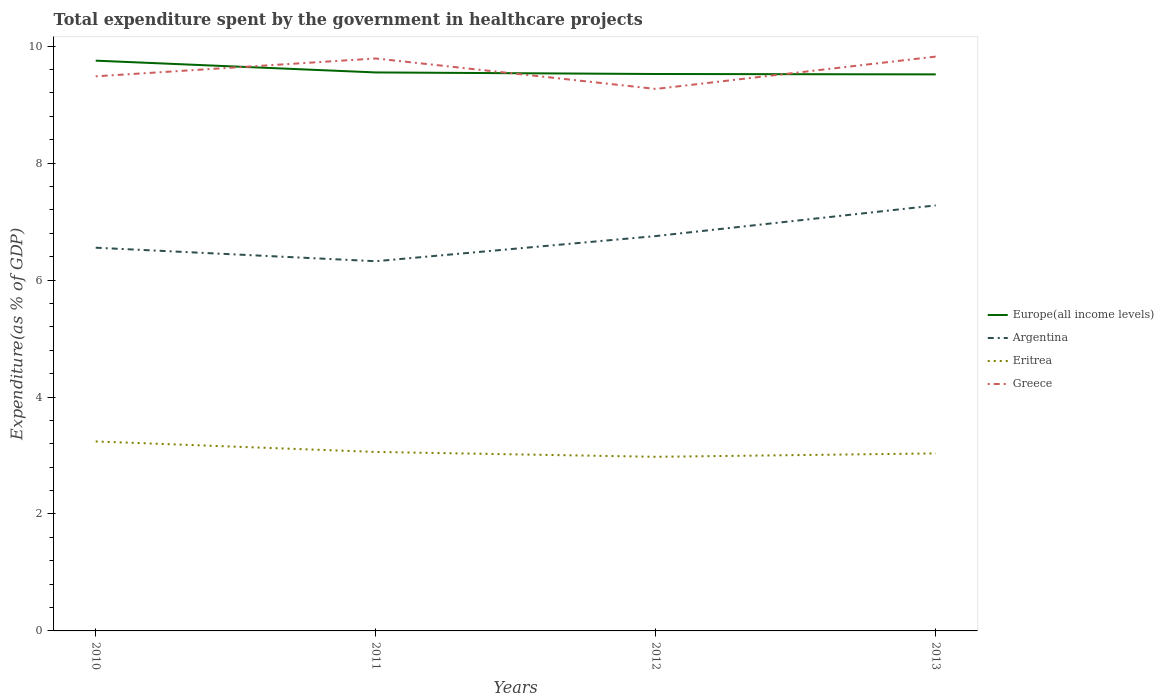Across all years, what is the maximum total expenditure spent by the government in healthcare projects in Greece?
Give a very brief answer. 9.27. What is the total total expenditure spent by the government in healthcare projects in Europe(all income levels) in the graph?
Make the answer very short. 0.2. What is the difference between the highest and the second highest total expenditure spent by the government in healthcare projects in Argentina?
Offer a very short reply. 0.95. Are the values on the major ticks of Y-axis written in scientific E-notation?
Give a very brief answer. No. What is the title of the graph?
Provide a succinct answer. Total expenditure spent by the government in healthcare projects. Does "Moldova" appear as one of the legend labels in the graph?
Provide a short and direct response. No. What is the label or title of the X-axis?
Make the answer very short. Years. What is the label or title of the Y-axis?
Your answer should be very brief. Expenditure(as % of GDP). What is the Expenditure(as % of GDP) of Europe(all income levels) in 2010?
Make the answer very short. 9.75. What is the Expenditure(as % of GDP) in Argentina in 2010?
Provide a short and direct response. 6.55. What is the Expenditure(as % of GDP) of Eritrea in 2010?
Your answer should be compact. 3.24. What is the Expenditure(as % of GDP) in Greece in 2010?
Give a very brief answer. 9.48. What is the Expenditure(as % of GDP) of Europe(all income levels) in 2011?
Provide a short and direct response. 9.55. What is the Expenditure(as % of GDP) of Argentina in 2011?
Your answer should be compact. 6.32. What is the Expenditure(as % of GDP) in Eritrea in 2011?
Give a very brief answer. 3.06. What is the Expenditure(as % of GDP) of Greece in 2011?
Ensure brevity in your answer.  9.79. What is the Expenditure(as % of GDP) in Europe(all income levels) in 2012?
Keep it short and to the point. 9.52. What is the Expenditure(as % of GDP) of Argentina in 2012?
Provide a succinct answer. 6.75. What is the Expenditure(as % of GDP) in Eritrea in 2012?
Offer a very short reply. 2.98. What is the Expenditure(as % of GDP) of Greece in 2012?
Your answer should be very brief. 9.27. What is the Expenditure(as % of GDP) of Europe(all income levels) in 2013?
Your response must be concise. 9.52. What is the Expenditure(as % of GDP) of Argentina in 2013?
Keep it short and to the point. 7.28. What is the Expenditure(as % of GDP) in Eritrea in 2013?
Keep it short and to the point. 3.04. What is the Expenditure(as % of GDP) of Greece in 2013?
Your response must be concise. 9.82. Across all years, what is the maximum Expenditure(as % of GDP) of Europe(all income levels)?
Offer a very short reply. 9.75. Across all years, what is the maximum Expenditure(as % of GDP) of Argentina?
Make the answer very short. 7.28. Across all years, what is the maximum Expenditure(as % of GDP) of Eritrea?
Give a very brief answer. 3.24. Across all years, what is the maximum Expenditure(as % of GDP) in Greece?
Offer a terse response. 9.82. Across all years, what is the minimum Expenditure(as % of GDP) of Europe(all income levels)?
Provide a succinct answer. 9.52. Across all years, what is the minimum Expenditure(as % of GDP) of Argentina?
Offer a very short reply. 6.32. Across all years, what is the minimum Expenditure(as % of GDP) of Eritrea?
Provide a short and direct response. 2.98. Across all years, what is the minimum Expenditure(as % of GDP) in Greece?
Give a very brief answer. 9.27. What is the total Expenditure(as % of GDP) of Europe(all income levels) in the graph?
Ensure brevity in your answer.  38.34. What is the total Expenditure(as % of GDP) in Argentina in the graph?
Your response must be concise. 26.91. What is the total Expenditure(as % of GDP) of Eritrea in the graph?
Offer a terse response. 12.31. What is the total Expenditure(as % of GDP) in Greece in the graph?
Provide a succinct answer. 38.36. What is the difference between the Expenditure(as % of GDP) of Europe(all income levels) in 2010 and that in 2011?
Offer a very short reply. 0.2. What is the difference between the Expenditure(as % of GDP) of Argentina in 2010 and that in 2011?
Offer a terse response. 0.23. What is the difference between the Expenditure(as % of GDP) of Eritrea in 2010 and that in 2011?
Your answer should be very brief. 0.18. What is the difference between the Expenditure(as % of GDP) in Greece in 2010 and that in 2011?
Provide a short and direct response. -0.31. What is the difference between the Expenditure(as % of GDP) of Europe(all income levels) in 2010 and that in 2012?
Provide a succinct answer. 0.23. What is the difference between the Expenditure(as % of GDP) of Argentina in 2010 and that in 2012?
Ensure brevity in your answer.  -0.2. What is the difference between the Expenditure(as % of GDP) of Eritrea in 2010 and that in 2012?
Ensure brevity in your answer.  0.26. What is the difference between the Expenditure(as % of GDP) in Greece in 2010 and that in 2012?
Provide a succinct answer. 0.22. What is the difference between the Expenditure(as % of GDP) of Europe(all income levels) in 2010 and that in 2013?
Your answer should be very brief. 0.23. What is the difference between the Expenditure(as % of GDP) in Argentina in 2010 and that in 2013?
Offer a terse response. -0.72. What is the difference between the Expenditure(as % of GDP) of Eritrea in 2010 and that in 2013?
Your response must be concise. 0.2. What is the difference between the Expenditure(as % of GDP) of Greece in 2010 and that in 2013?
Provide a succinct answer. -0.34. What is the difference between the Expenditure(as % of GDP) in Europe(all income levels) in 2011 and that in 2012?
Give a very brief answer. 0.03. What is the difference between the Expenditure(as % of GDP) of Argentina in 2011 and that in 2012?
Provide a succinct answer. -0.43. What is the difference between the Expenditure(as % of GDP) of Eritrea in 2011 and that in 2012?
Make the answer very short. 0.08. What is the difference between the Expenditure(as % of GDP) of Greece in 2011 and that in 2012?
Provide a succinct answer. 0.52. What is the difference between the Expenditure(as % of GDP) in Europe(all income levels) in 2011 and that in 2013?
Your answer should be compact. 0.03. What is the difference between the Expenditure(as % of GDP) of Argentina in 2011 and that in 2013?
Your answer should be compact. -0.95. What is the difference between the Expenditure(as % of GDP) in Eritrea in 2011 and that in 2013?
Give a very brief answer. 0.03. What is the difference between the Expenditure(as % of GDP) in Greece in 2011 and that in 2013?
Ensure brevity in your answer.  -0.03. What is the difference between the Expenditure(as % of GDP) in Europe(all income levels) in 2012 and that in 2013?
Offer a terse response. 0.01. What is the difference between the Expenditure(as % of GDP) of Argentina in 2012 and that in 2013?
Provide a succinct answer. -0.52. What is the difference between the Expenditure(as % of GDP) of Eritrea in 2012 and that in 2013?
Keep it short and to the point. -0.06. What is the difference between the Expenditure(as % of GDP) of Greece in 2012 and that in 2013?
Offer a terse response. -0.55. What is the difference between the Expenditure(as % of GDP) of Europe(all income levels) in 2010 and the Expenditure(as % of GDP) of Argentina in 2011?
Your response must be concise. 3.43. What is the difference between the Expenditure(as % of GDP) of Europe(all income levels) in 2010 and the Expenditure(as % of GDP) of Eritrea in 2011?
Offer a terse response. 6.69. What is the difference between the Expenditure(as % of GDP) in Europe(all income levels) in 2010 and the Expenditure(as % of GDP) in Greece in 2011?
Give a very brief answer. -0.04. What is the difference between the Expenditure(as % of GDP) in Argentina in 2010 and the Expenditure(as % of GDP) in Eritrea in 2011?
Keep it short and to the point. 3.49. What is the difference between the Expenditure(as % of GDP) of Argentina in 2010 and the Expenditure(as % of GDP) of Greece in 2011?
Keep it short and to the point. -3.24. What is the difference between the Expenditure(as % of GDP) of Eritrea in 2010 and the Expenditure(as % of GDP) of Greece in 2011?
Give a very brief answer. -6.55. What is the difference between the Expenditure(as % of GDP) in Europe(all income levels) in 2010 and the Expenditure(as % of GDP) in Argentina in 2012?
Your answer should be compact. 3. What is the difference between the Expenditure(as % of GDP) of Europe(all income levels) in 2010 and the Expenditure(as % of GDP) of Eritrea in 2012?
Give a very brief answer. 6.77. What is the difference between the Expenditure(as % of GDP) of Europe(all income levels) in 2010 and the Expenditure(as % of GDP) of Greece in 2012?
Your answer should be compact. 0.48. What is the difference between the Expenditure(as % of GDP) of Argentina in 2010 and the Expenditure(as % of GDP) of Eritrea in 2012?
Your response must be concise. 3.58. What is the difference between the Expenditure(as % of GDP) of Argentina in 2010 and the Expenditure(as % of GDP) of Greece in 2012?
Give a very brief answer. -2.72. What is the difference between the Expenditure(as % of GDP) of Eritrea in 2010 and the Expenditure(as % of GDP) of Greece in 2012?
Ensure brevity in your answer.  -6.03. What is the difference between the Expenditure(as % of GDP) in Europe(all income levels) in 2010 and the Expenditure(as % of GDP) in Argentina in 2013?
Make the answer very short. 2.48. What is the difference between the Expenditure(as % of GDP) of Europe(all income levels) in 2010 and the Expenditure(as % of GDP) of Eritrea in 2013?
Make the answer very short. 6.72. What is the difference between the Expenditure(as % of GDP) of Europe(all income levels) in 2010 and the Expenditure(as % of GDP) of Greece in 2013?
Make the answer very short. -0.07. What is the difference between the Expenditure(as % of GDP) in Argentina in 2010 and the Expenditure(as % of GDP) in Eritrea in 2013?
Keep it short and to the point. 3.52. What is the difference between the Expenditure(as % of GDP) of Argentina in 2010 and the Expenditure(as % of GDP) of Greece in 2013?
Offer a very short reply. -3.27. What is the difference between the Expenditure(as % of GDP) in Eritrea in 2010 and the Expenditure(as % of GDP) in Greece in 2013?
Your answer should be very brief. -6.58. What is the difference between the Expenditure(as % of GDP) of Europe(all income levels) in 2011 and the Expenditure(as % of GDP) of Argentina in 2012?
Provide a short and direct response. 2.8. What is the difference between the Expenditure(as % of GDP) of Europe(all income levels) in 2011 and the Expenditure(as % of GDP) of Eritrea in 2012?
Provide a succinct answer. 6.57. What is the difference between the Expenditure(as % of GDP) in Europe(all income levels) in 2011 and the Expenditure(as % of GDP) in Greece in 2012?
Provide a succinct answer. 0.28. What is the difference between the Expenditure(as % of GDP) in Argentina in 2011 and the Expenditure(as % of GDP) in Eritrea in 2012?
Provide a short and direct response. 3.34. What is the difference between the Expenditure(as % of GDP) of Argentina in 2011 and the Expenditure(as % of GDP) of Greece in 2012?
Ensure brevity in your answer.  -2.95. What is the difference between the Expenditure(as % of GDP) in Eritrea in 2011 and the Expenditure(as % of GDP) in Greece in 2012?
Offer a terse response. -6.21. What is the difference between the Expenditure(as % of GDP) in Europe(all income levels) in 2011 and the Expenditure(as % of GDP) in Argentina in 2013?
Offer a very short reply. 2.27. What is the difference between the Expenditure(as % of GDP) in Europe(all income levels) in 2011 and the Expenditure(as % of GDP) in Eritrea in 2013?
Make the answer very short. 6.52. What is the difference between the Expenditure(as % of GDP) in Europe(all income levels) in 2011 and the Expenditure(as % of GDP) in Greece in 2013?
Offer a terse response. -0.27. What is the difference between the Expenditure(as % of GDP) of Argentina in 2011 and the Expenditure(as % of GDP) of Eritrea in 2013?
Ensure brevity in your answer.  3.29. What is the difference between the Expenditure(as % of GDP) in Argentina in 2011 and the Expenditure(as % of GDP) in Greece in 2013?
Offer a terse response. -3.5. What is the difference between the Expenditure(as % of GDP) in Eritrea in 2011 and the Expenditure(as % of GDP) in Greece in 2013?
Your answer should be very brief. -6.76. What is the difference between the Expenditure(as % of GDP) in Europe(all income levels) in 2012 and the Expenditure(as % of GDP) in Argentina in 2013?
Keep it short and to the point. 2.25. What is the difference between the Expenditure(as % of GDP) in Europe(all income levels) in 2012 and the Expenditure(as % of GDP) in Eritrea in 2013?
Your response must be concise. 6.49. What is the difference between the Expenditure(as % of GDP) of Europe(all income levels) in 2012 and the Expenditure(as % of GDP) of Greece in 2013?
Provide a short and direct response. -0.3. What is the difference between the Expenditure(as % of GDP) of Argentina in 2012 and the Expenditure(as % of GDP) of Eritrea in 2013?
Make the answer very short. 3.72. What is the difference between the Expenditure(as % of GDP) in Argentina in 2012 and the Expenditure(as % of GDP) in Greece in 2013?
Your answer should be very brief. -3.07. What is the difference between the Expenditure(as % of GDP) in Eritrea in 2012 and the Expenditure(as % of GDP) in Greece in 2013?
Provide a short and direct response. -6.84. What is the average Expenditure(as % of GDP) of Europe(all income levels) per year?
Offer a very short reply. 9.59. What is the average Expenditure(as % of GDP) in Argentina per year?
Your answer should be very brief. 6.73. What is the average Expenditure(as % of GDP) of Eritrea per year?
Provide a succinct answer. 3.08. What is the average Expenditure(as % of GDP) in Greece per year?
Give a very brief answer. 9.59. In the year 2010, what is the difference between the Expenditure(as % of GDP) in Europe(all income levels) and Expenditure(as % of GDP) in Argentina?
Make the answer very short. 3.2. In the year 2010, what is the difference between the Expenditure(as % of GDP) in Europe(all income levels) and Expenditure(as % of GDP) in Eritrea?
Make the answer very short. 6.51. In the year 2010, what is the difference between the Expenditure(as % of GDP) of Europe(all income levels) and Expenditure(as % of GDP) of Greece?
Provide a short and direct response. 0.27. In the year 2010, what is the difference between the Expenditure(as % of GDP) of Argentina and Expenditure(as % of GDP) of Eritrea?
Ensure brevity in your answer.  3.31. In the year 2010, what is the difference between the Expenditure(as % of GDP) in Argentina and Expenditure(as % of GDP) in Greece?
Your response must be concise. -2.93. In the year 2010, what is the difference between the Expenditure(as % of GDP) of Eritrea and Expenditure(as % of GDP) of Greece?
Make the answer very short. -6.24. In the year 2011, what is the difference between the Expenditure(as % of GDP) in Europe(all income levels) and Expenditure(as % of GDP) in Argentina?
Offer a very short reply. 3.23. In the year 2011, what is the difference between the Expenditure(as % of GDP) in Europe(all income levels) and Expenditure(as % of GDP) in Eritrea?
Give a very brief answer. 6.49. In the year 2011, what is the difference between the Expenditure(as % of GDP) of Europe(all income levels) and Expenditure(as % of GDP) of Greece?
Provide a succinct answer. -0.24. In the year 2011, what is the difference between the Expenditure(as % of GDP) in Argentina and Expenditure(as % of GDP) in Eritrea?
Your answer should be compact. 3.26. In the year 2011, what is the difference between the Expenditure(as % of GDP) in Argentina and Expenditure(as % of GDP) in Greece?
Offer a terse response. -3.47. In the year 2011, what is the difference between the Expenditure(as % of GDP) in Eritrea and Expenditure(as % of GDP) in Greece?
Give a very brief answer. -6.73. In the year 2012, what is the difference between the Expenditure(as % of GDP) in Europe(all income levels) and Expenditure(as % of GDP) in Argentina?
Your answer should be compact. 2.77. In the year 2012, what is the difference between the Expenditure(as % of GDP) in Europe(all income levels) and Expenditure(as % of GDP) in Eritrea?
Your answer should be very brief. 6.55. In the year 2012, what is the difference between the Expenditure(as % of GDP) in Europe(all income levels) and Expenditure(as % of GDP) in Greece?
Provide a short and direct response. 0.26. In the year 2012, what is the difference between the Expenditure(as % of GDP) of Argentina and Expenditure(as % of GDP) of Eritrea?
Your answer should be very brief. 3.77. In the year 2012, what is the difference between the Expenditure(as % of GDP) of Argentina and Expenditure(as % of GDP) of Greece?
Provide a short and direct response. -2.52. In the year 2012, what is the difference between the Expenditure(as % of GDP) of Eritrea and Expenditure(as % of GDP) of Greece?
Provide a succinct answer. -6.29. In the year 2013, what is the difference between the Expenditure(as % of GDP) in Europe(all income levels) and Expenditure(as % of GDP) in Argentina?
Your answer should be very brief. 2.24. In the year 2013, what is the difference between the Expenditure(as % of GDP) of Europe(all income levels) and Expenditure(as % of GDP) of Eritrea?
Your answer should be very brief. 6.48. In the year 2013, what is the difference between the Expenditure(as % of GDP) in Europe(all income levels) and Expenditure(as % of GDP) in Greece?
Your answer should be very brief. -0.3. In the year 2013, what is the difference between the Expenditure(as % of GDP) of Argentina and Expenditure(as % of GDP) of Eritrea?
Provide a succinct answer. 4.24. In the year 2013, what is the difference between the Expenditure(as % of GDP) of Argentina and Expenditure(as % of GDP) of Greece?
Offer a very short reply. -2.54. In the year 2013, what is the difference between the Expenditure(as % of GDP) in Eritrea and Expenditure(as % of GDP) in Greece?
Your answer should be very brief. -6.79. What is the ratio of the Expenditure(as % of GDP) of Europe(all income levels) in 2010 to that in 2011?
Keep it short and to the point. 1.02. What is the ratio of the Expenditure(as % of GDP) in Argentina in 2010 to that in 2011?
Give a very brief answer. 1.04. What is the ratio of the Expenditure(as % of GDP) in Eritrea in 2010 to that in 2011?
Your answer should be compact. 1.06. What is the ratio of the Expenditure(as % of GDP) in Greece in 2010 to that in 2011?
Your answer should be very brief. 0.97. What is the ratio of the Expenditure(as % of GDP) of Europe(all income levels) in 2010 to that in 2012?
Offer a terse response. 1.02. What is the ratio of the Expenditure(as % of GDP) of Argentina in 2010 to that in 2012?
Offer a terse response. 0.97. What is the ratio of the Expenditure(as % of GDP) in Eritrea in 2010 to that in 2012?
Offer a terse response. 1.09. What is the ratio of the Expenditure(as % of GDP) of Greece in 2010 to that in 2012?
Your answer should be compact. 1.02. What is the ratio of the Expenditure(as % of GDP) of Europe(all income levels) in 2010 to that in 2013?
Your response must be concise. 1.02. What is the ratio of the Expenditure(as % of GDP) in Argentina in 2010 to that in 2013?
Ensure brevity in your answer.  0.9. What is the ratio of the Expenditure(as % of GDP) of Eritrea in 2010 to that in 2013?
Give a very brief answer. 1.07. What is the ratio of the Expenditure(as % of GDP) in Greece in 2010 to that in 2013?
Give a very brief answer. 0.97. What is the ratio of the Expenditure(as % of GDP) in Argentina in 2011 to that in 2012?
Provide a succinct answer. 0.94. What is the ratio of the Expenditure(as % of GDP) of Eritrea in 2011 to that in 2012?
Your response must be concise. 1.03. What is the ratio of the Expenditure(as % of GDP) of Greece in 2011 to that in 2012?
Make the answer very short. 1.06. What is the ratio of the Expenditure(as % of GDP) in Argentina in 2011 to that in 2013?
Your answer should be very brief. 0.87. What is the ratio of the Expenditure(as % of GDP) in Eritrea in 2011 to that in 2013?
Make the answer very short. 1.01. What is the ratio of the Expenditure(as % of GDP) in Greece in 2011 to that in 2013?
Ensure brevity in your answer.  1. What is the ratio of the Expenditure(as % of GDP) in Argentina in 2012 to that in 2013?
Keep it short and to the point. 0.93. What is the ratio of the Expenditure(as % of GDP) of Eritrea in 2012 to that in 2013?
Give a very brief answer. 0.98. What is the ratio of the Expenditure(as % of GDP) in Greece in 2012 to that in 2013?
Your answer should be very brief. 0.94. What is the difference between the highest and the second highest Expenditure(as % of GDP) of Europe(all income levels)?
Offer a terse response. 0.2. What is the difference between the highest and the second highest Expenditure(as % of GDP) in Argentina?
Offer a very short reply. 0.52. What is the difference between the highest and the second highest Expenditure(as % of GDP) in Eritrea?
Your answer should be very brief. 0.18. What is the difference between the highest and the second highest Expenditure(as % of GDP) of Greece?
Offer a very short reply. 0.03. What is the difference between the highest and the lowest Expenditure(as % of GDP) in Europe(all income levels)?
Your response must be concise. 0.23. What is the difference between the highest and the lowest Expenditure(as % of GDP) in Argentina?
Provide a short and direct response. 0.95. What is the difference between the highest and the lowest Expenditure(as % of GDP) in Eritrea?
Keep it short and to the point. 0.26. What is the difference between the highest and the lowest Expenditure(as % of GDP) of Greece?
Keep it short and to the point. 0.55. 